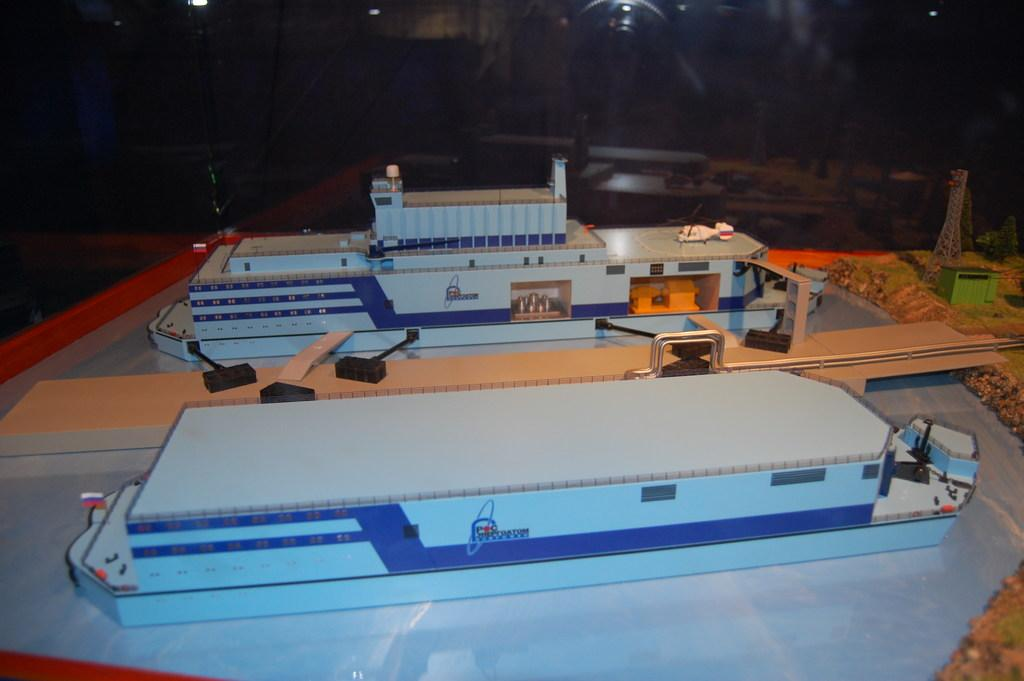What color can be seen on the objects in the image? There are blue colored things in the image. What is written on the blue colored objects? There is writing on the blue colored things. What can be observed about the background of the image? The background of the image is dark. What type of door is depicted in the image? There is no door present in the image. What story is being told through the writing on the blue objects? The image does not depict a story; it only shows blue objects with writing on them. 